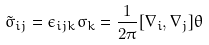<formula> <loc_0><loc_0><loc_500><loc_500>\tilde { \sigma } _ { i j } = \epsilon _ { i j k } \sigma _ { k } = \frac { 1 } { 2 \pi } [ \nabla _ { i } , \nabla _ { j } ] \theta</formula> 